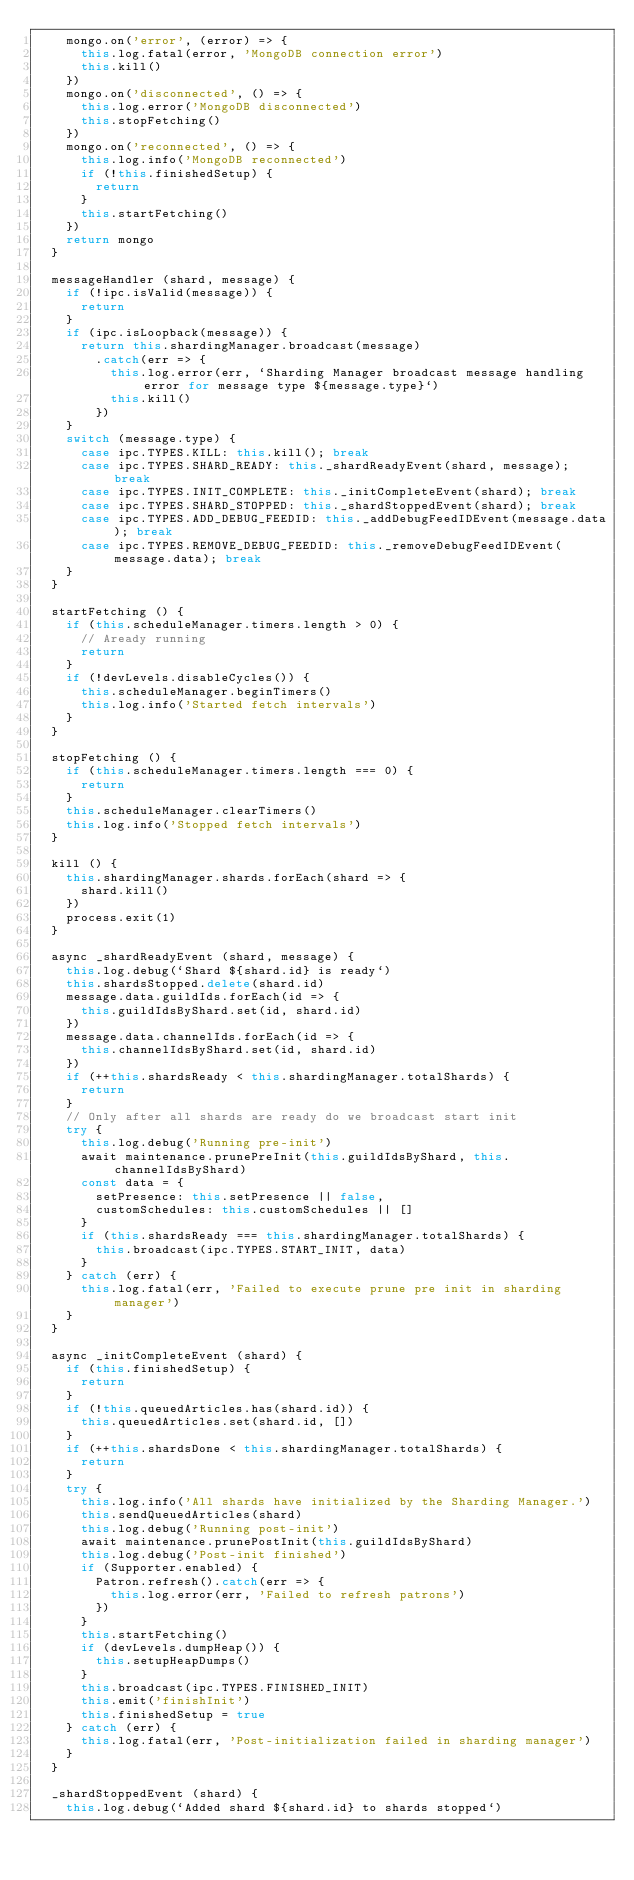<code> <loc_0><loc_0><loc_500><loc_500><_JavaScript_>    mongo.on('error', (error) => {
      this.log.fatal(error, 'MongoDB connection error')
      this.kill()
    })
    mongo.on('disconnected', () => {
      this.log.error('MongoDB disconnected')
      this.stopFetching()
    })
    mongo.on('reconnected', () => {
      this.log.info('MongoDB reconnected')
      if (!this.finishedSetup) {
        return
      }
      this.startFetching()
    })
    return mongo
  }

  messageHandler (shard, message) {
    if (!ipc.isValid(message)) {
      return
    }
    if (ipc.isLoopback(message)) {
      return this.shardingManager.broadcast(message)
        .catch(err => {
          this.log.error(err, `Sharding Manager broadcast message handling error for message type ${message.type}`)
          this.kill()
        })
    }
    switch (message.type) {
      case ipc.TYPES.KILL: this.kill(); break
      case ipc.TYPES.SHARD_READY: this._shardReadyEvent(shard, message); break
      case ipc.TYPES.INIT_COMPLETE: this._initCompleteEvent(shard); break
      case ipc.TYPES.SHARD_STOPPED: this._shardStoppedEvent(shard); break
      case ipc.TYPES.ADD_DEBUG_FEEDID: this._addDebugFeedIDEvent(message.data); break
      case ipc.TYPES.REMOVE_DEBUG_FEEDID: this._removeDebugFeedIDEvent(message.data); break
    }
  }

  startFetching () {
    if (this.scheduleManager.timers.length > 0) {
      // Aready running
      return
    }
    if (!devLevels.disableCycles()) {
      this.scheduleManager.beginTimers()
      this.log.info('Started fetch intervals')
    }
  }

  stopFetching () {
    if (this.scheduleManager.timers.length === 0) {
      return
    }
    this.scheduleManager.clearTimers()
    this.log.info('Stopped fetch intervals')
  }

  kill () {
    this.shardingManager.shards.forEach(shard => {
      shard.kill()
    })
    process.exit(1)
  }

  async _shardReadyEvent (shard, message) {
    this.log.debug(`Shard ${shard.id} is ready`)
    this.shardsStopped.delete(shard.id)
    message.data.guildIds.forEach(id => {
      this.guildIdsByShard.set(id, shard.id)
    })
    message.data.channelIds.forEach(id => {
      this.channelIdsByShard.set(id, shard.id)
    })
    if (++this.shardsReady < this.shardingManager.totalShards) {
      return
    }
    // Only after all shards are ready do we broadcast start init
    try {
      this.log.debug('Running pre-init')
      await maintenance.prunePreInit(this.guildIdsByShard, this.channelIdsByShard)
      const data = {
        setPresence: this.setPresence || false,
        customSchedules: this.customSchedules || []
      }
      if (this.shardsReady === this.shardingManager.totalShards) {
        this.broadcast(ipc.TYPES.START_INIT, data)
      }
    } catch (err) {
      this.log.fatal(err, 'Failed to execute prune pre init in sharding manager')
    }
  }

  async _initCompleteEvent (shard) {
    if (this.finishedSetup) {
      return
    }
    if (!this.queuedArticles.has(shard.id)) {
      this.queuedArticles.set(shard.id, [])
    }
    if (++this.shardsDone < this.shardingManager.totalShards) {
      return
    }
    try {
      this.log.info('All shards have initialized by the Sharding Manager.')
      this.sendQueuedArticles(shard)
      this.log.debug('Running post-init')
      await maintenance.prunePostInit(this.guildIdsByShard)
      this.log.debug('Post-init finished')
      if (Supporter.enabled) {
        Patron.refresh().catch(err => {
          this.log.error(err, 'Failed to refresh patrons')
        })
      }
      this.startFetching()
      if (devLevels.dumpHeap()) {
        this.setupHeapDumps()
      }
      this.broadcast(ipc.TYPES.FINISHED_INIT)
      this.emit('finishInit')
      this.finishedSetup = true
    } catch (err) {
      this.log.fatal(err, 'Post-initialization failed in sharding manager')
    }
  }

  _shardStoppedEvent (shard) {
    this.log.debug(`Added shard ${shard.id} to shards stopped`)</code> 